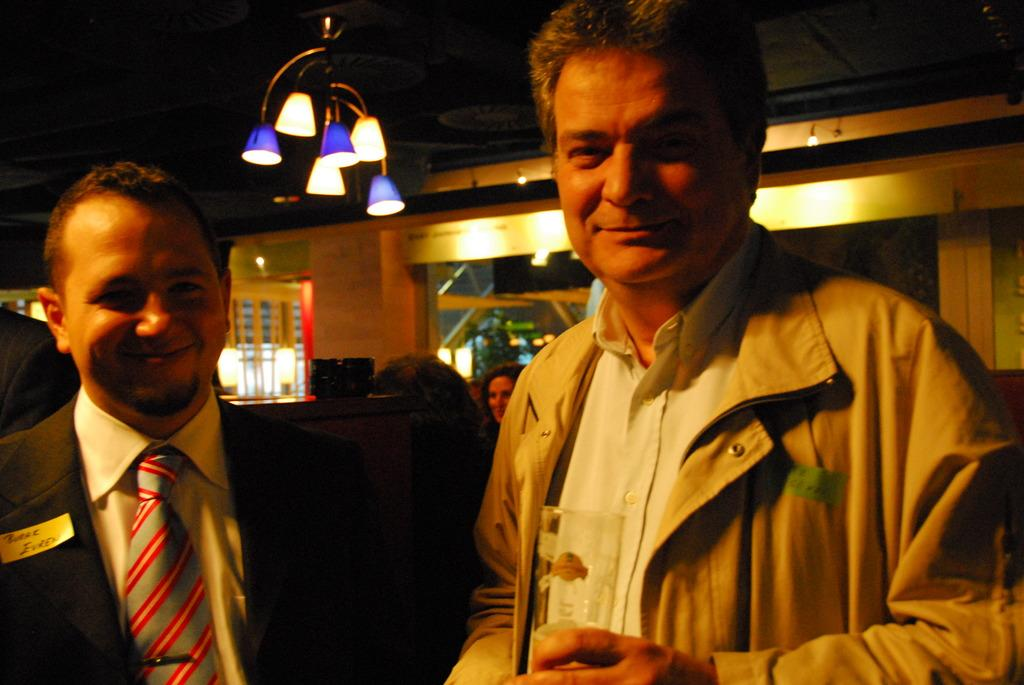How many people are in the image? There are two persons in the image. What are the two persons wearing? The two persons are wearing jackets. What are the two persons doing in the image? The two persons are standing in the front and smiling. Can you describe the background of the image? There are additional persons visible in the background. What can be seen on the ceiling in the image? There are lights over the ceiling in the image. What type of knee injury can be seen on the person in the image? There is no knee injury visible in the image; both persons are standing and smiling. 